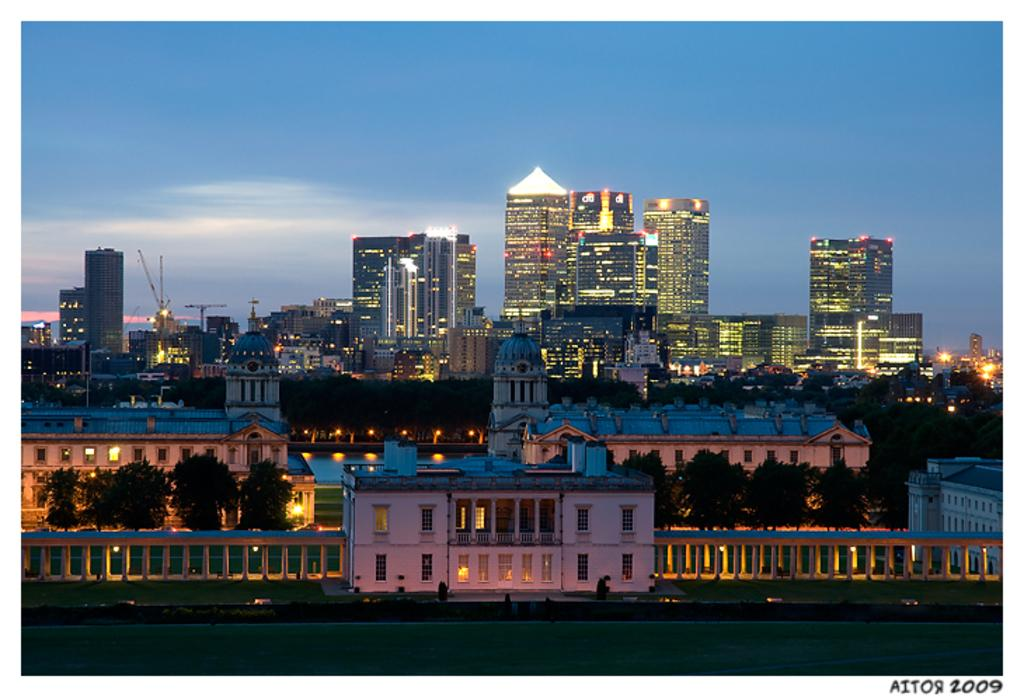What can be seen in the middle of the image? There are buildings and trees in the middle of the image. What is visible at the top of the image? The sky and clouds are visible at the top of the image. Where is the meeting taking place in the image? There is no meeting taking place in the image; it only shows buildings, trees, sky, and clouds. Can you see any flowers in the image? There are no flowers visible in the image. 